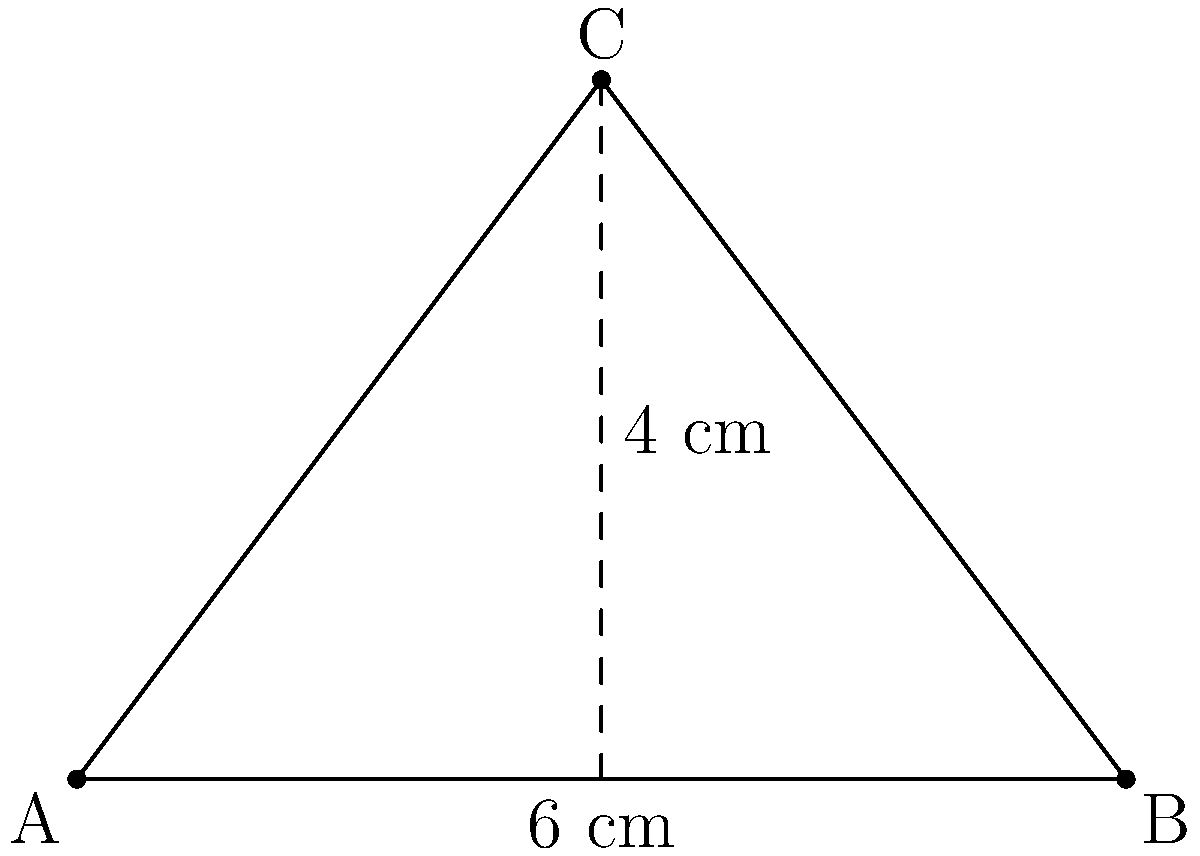Naga City's iconic triangle-shaped park, Plaza Quince Martires, is represented by the diagram above. If the base of the triangle is 6 cm and its height is 4 cm, what is the area of the park in square centimeters? To calculate the area of a triangle, we use the formula:

$$ A = \frac{1}{2} \times b \times h $$

Where:
$A$ = Area of the triangle
$b$ = Base of the triangle
$h$ = Height of the triangle

Given:
Base $(b) = 6$ cm
Height $(h) = 4$ cm

Let's substitute these values into the formula:

$$ A = \frac{1}{2} \times 6 \text{ cm} \times 4 \text{ cm} $$

$$ A = \frac{1}{2} \times 24 \text{ cm}^2 $$

$$ A = 12 \text{ cm}^2 $$

Therefore, the area of Plaza Quince Martires is 12 square centimeters.
Answer: 12 cm² 